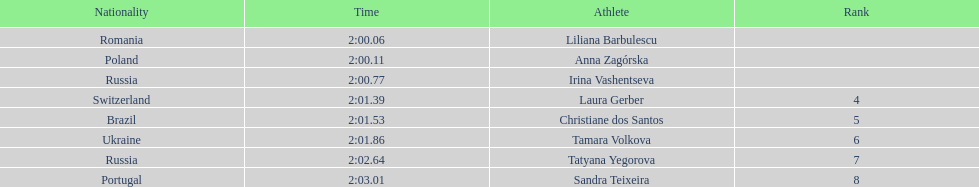How many runners finished with their time below 2:01? 3. 